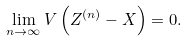<formula> <loc_0><loc_0><loc_500><loc_500>\lim _ { n \rightarrow \infty } V \left ( Z ^ { ( n ) } - X \right ) = 0 .</formula> 